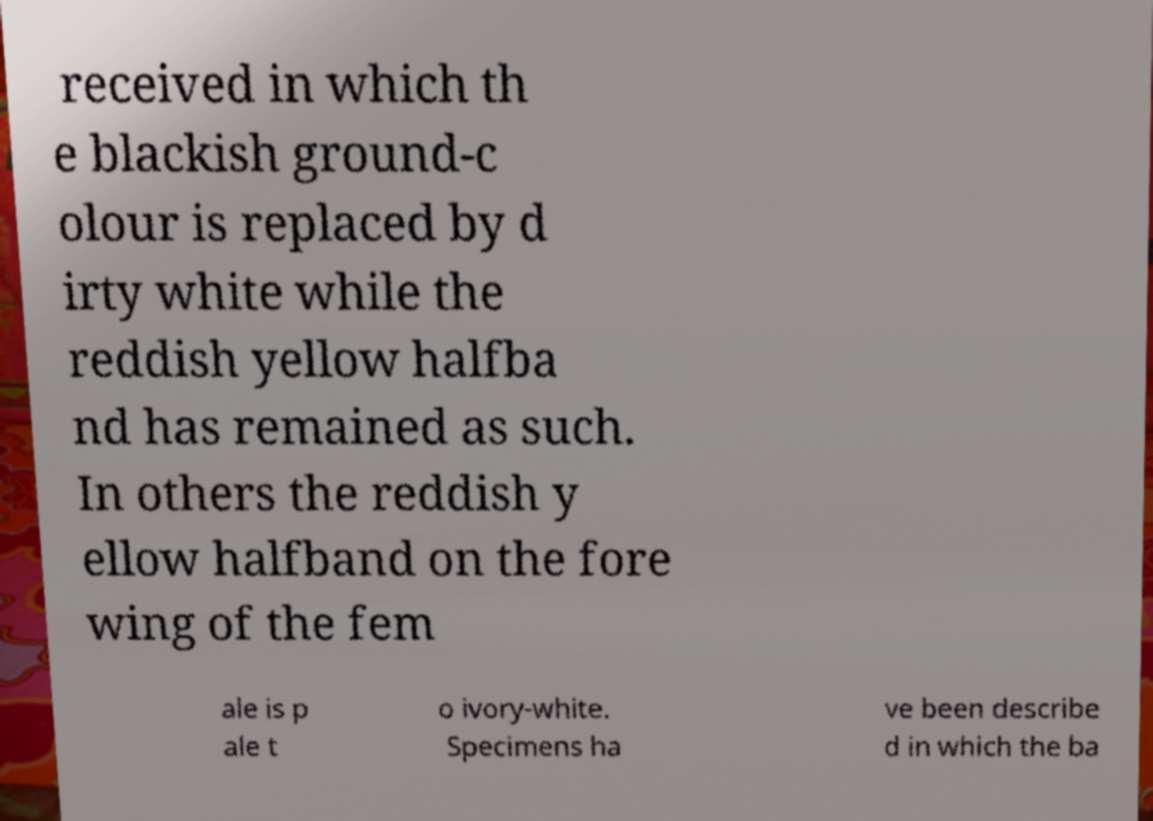Please read and relay the text visible in this image. What does it say? received in which th e blackish ground-c olour is replaced by d irty white while the reddish yellow halfba nd has remained as such. In others the reddish y ellow halfband on the fore wing of the fem ale is p ale t o ivory-white. Specimens ha ve been describe d in which the ba 